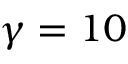Convert formula to latex. <formula><loc_0><loc_0><loc_500><loc_500>\gamma = 1 0</formula> 